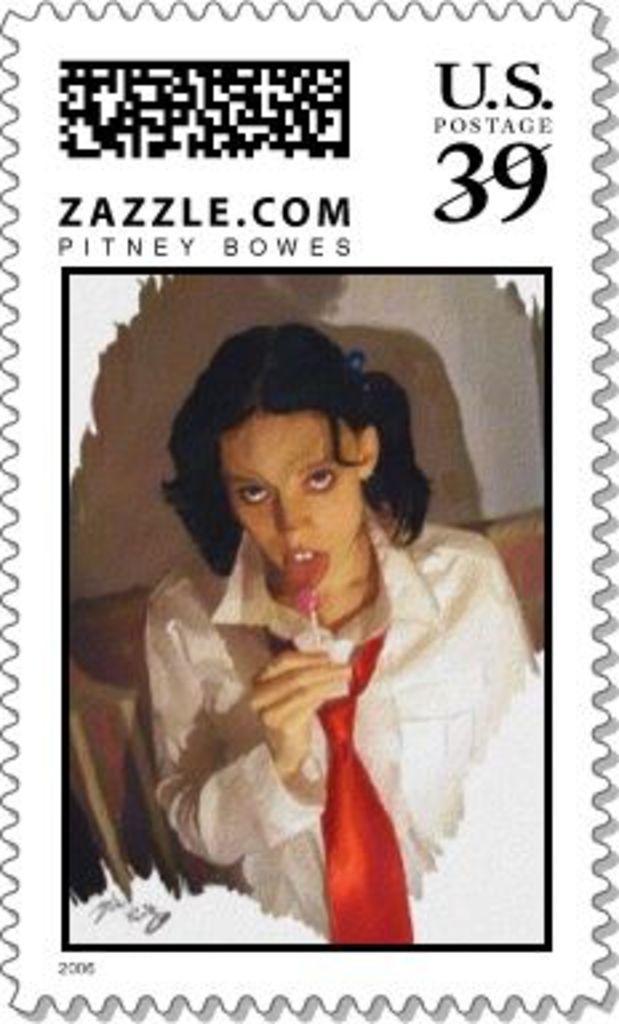How would you summarize this image in a sentence or two? This picture is a poster. At the top we can see the barcode and numbers. At the bottom we can see a woman who is eating lollipop and standing near to the chair and table. 